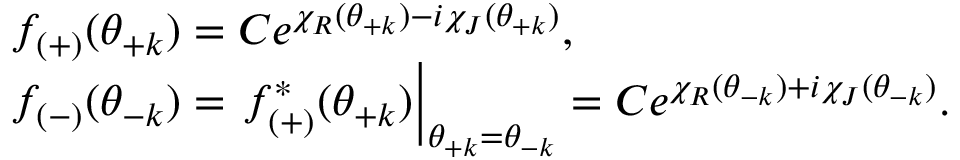Convert formula to latex. <formula><loc_0><loc_0><loc_500><loc_500>\begin{array} { l } { { f _ { ( + ) } ( \theta _ { + k } ) = C e ^ { \chi _ { R } ( \theta _ { + k } ) - i \chi _ { J } ( \theta _ { + k } ) } , } } \\ { { f _ { ( - ) } ( \theta _ { - k } ) = f _ { ( + ) } ^ { * } ( \theta _ { + k } ) \right | _ { \theta _ { + k } = \theta _ { - k } } = C e ^ { \chi _ { R } ( \theta _ { - k } ) + i \chi _ { J } ( \theta _ { - k } ) } . } } \end{array}</formula> 